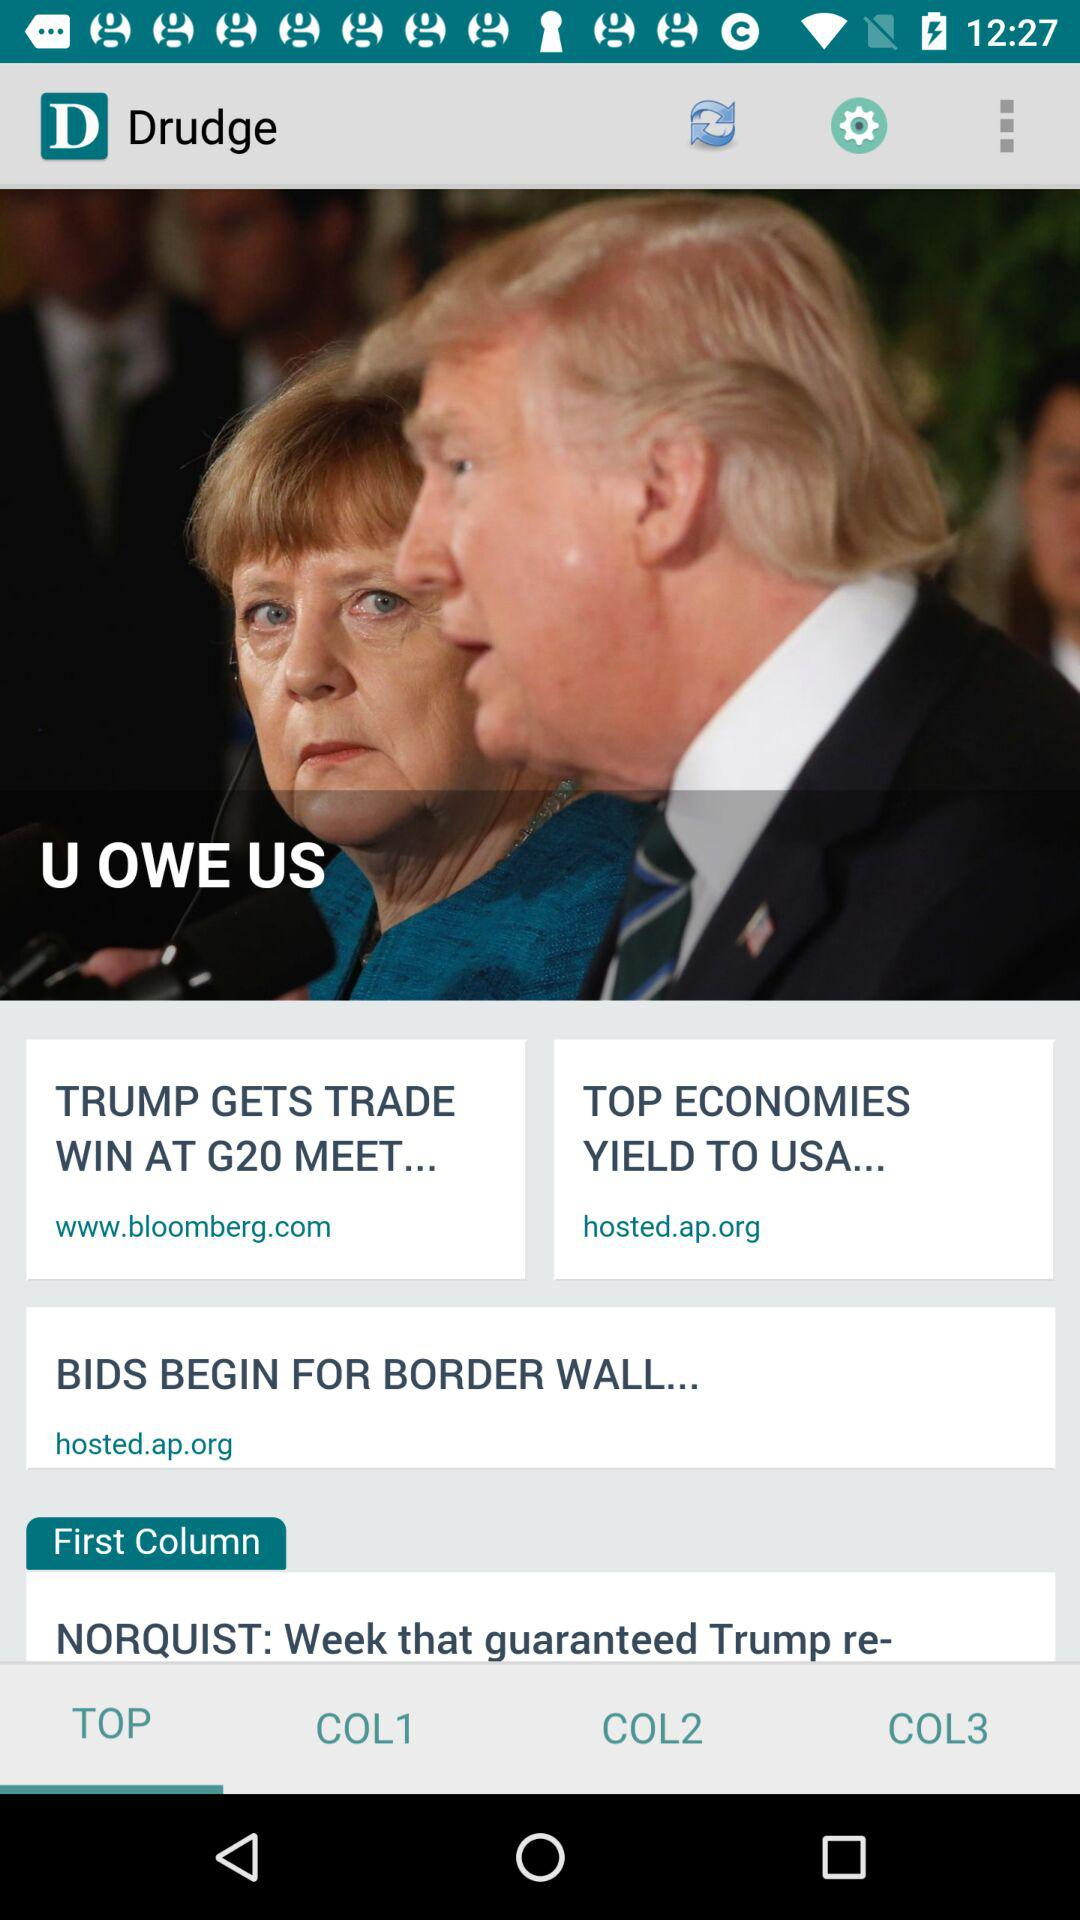What is the app name? The app name is "Drudge". 